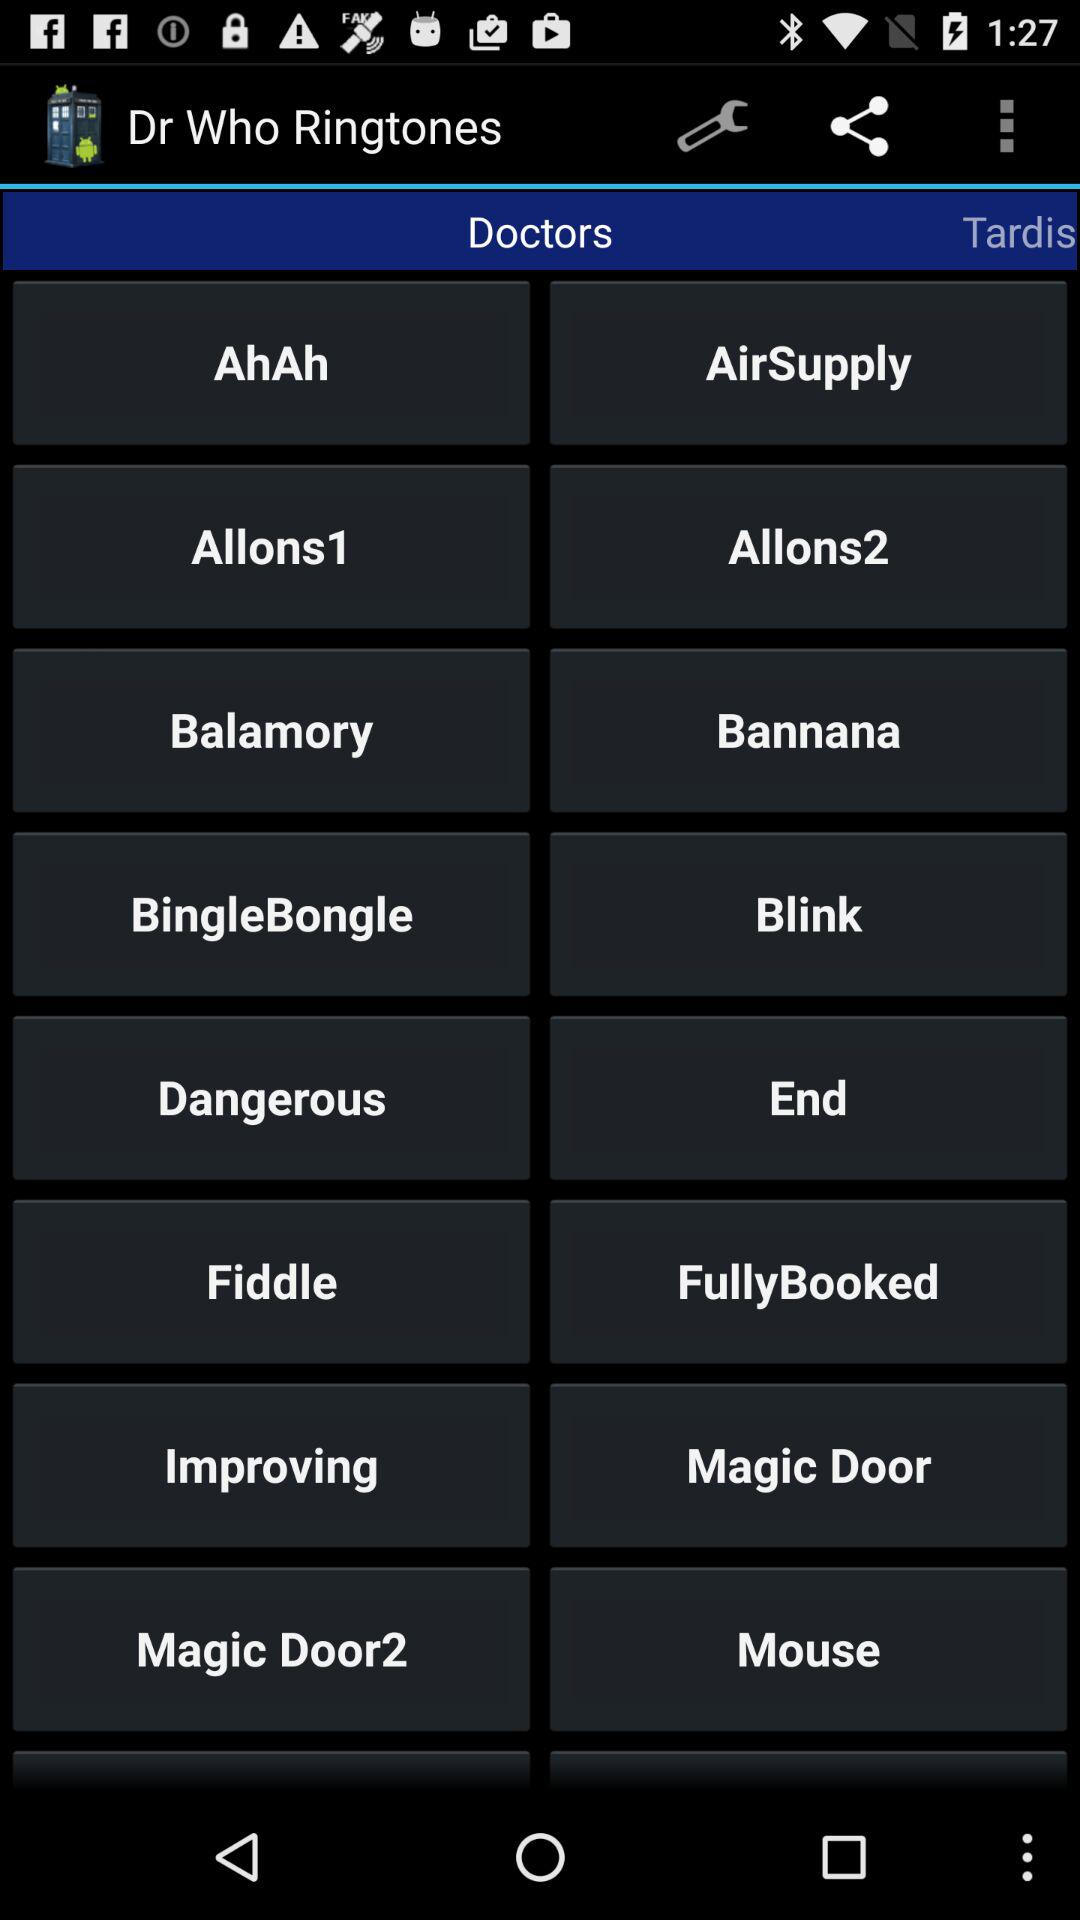What tab is selected? The selected tab is "Doctors". 